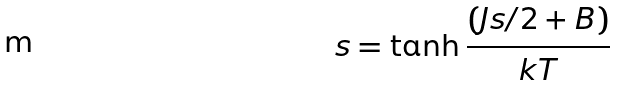<formula> <loc_0><loc_0><loc_500><loc_500>s = \tanh \frac { ( J s / 2 + B ) } { k T }</formula> 